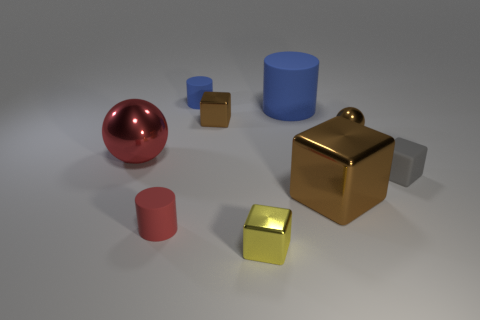Subtract all yellow cubes. How many cubes are left? 3 Subtract all big brown cubes. How many cubes are left? 3 Subtract all blue cubes. Subtract all cyan cylinders. How many cubes are left? 4 Add 1 large spheres. How many objects exist? 10 Subtract all blocks. How many objects are left? 5 Add 5 red matte objects. How many red matte objects are left? 6 Add 3 tiny purple blocks. How many tiny purple blocks exist? 3 Subtract 1 red balls. How many objects are left? 8 Subtract all large shiny things. Subtract all tiny brown metallic cubes. How many objects are left? 6 